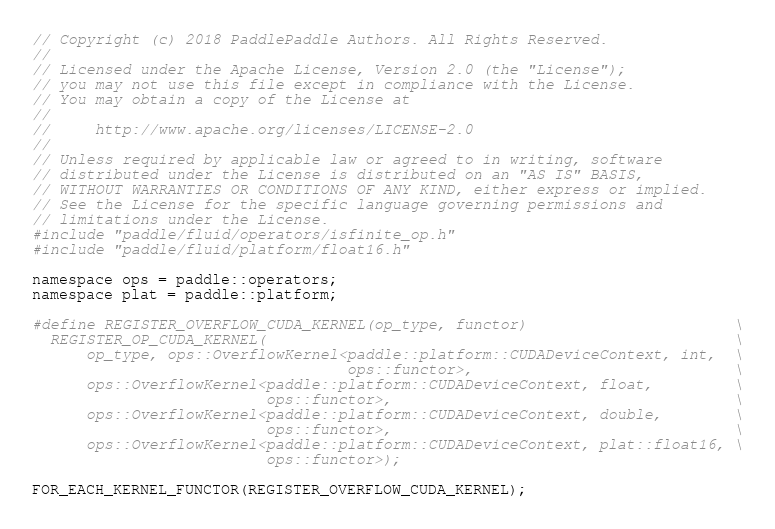Convert code to text. <code><loc_0><loc_0><loc_500><loc_500><_Cuda_>// Copyright (c) 2018 PaddlePaddle Authors. All Rights Reserved.
//
// Licensed under the Apache License, Version 2.0 (the "License");
// you may not use this file except in compliance with the License.
// You may obtain a copy of the License at
//
//     http://www.apache.org/licenses/LICENSE-2.0
//
// Unless required by applicable law or agreed to in writing, software
// distributed under the License is distributed on an "AS IS" BASIS,
// WITHOUT WARRANTIES OR CONDITIONS OF ANY KIND, either express or implied.
// See the License for the specific language governing permissions and
// limitations under the License.
#include "paddle/fluid/operators/isfinite_op.h"
#include "paddle/fluid/platform/float16.h"

namespace ops = paddle::operators;
namespace plat = paddle::platform;

#define REGISTER_OVERFLOW_CUDA_KERNEL(op_type, functor)                       \
  REGISTER_OP_CUDA_KERNEL(                                                    \
      op_type, ops::OverflowKernel<paddle::platform::CUDADeviceContext, int,  \
                                   ops::functor>,                             \
      ops::OverflowKernel<paddle::platform::CUDADeviceContext, float,         \
                          ops::functor>,                                      \
      ops::OverflowKernel<paddle::platform::CUDADeviceContext, double,        \
                          ops::functor>,                                      \
      ops::OverflowKernel<paddle::platform::CUDADeviceContext, plat::float16, \
                          ops::functor>);

FOR_EACH_KERNEL_FUNCTOR(REGISTER_OVERFLOW_CUDA_KERNEL);
</code> 